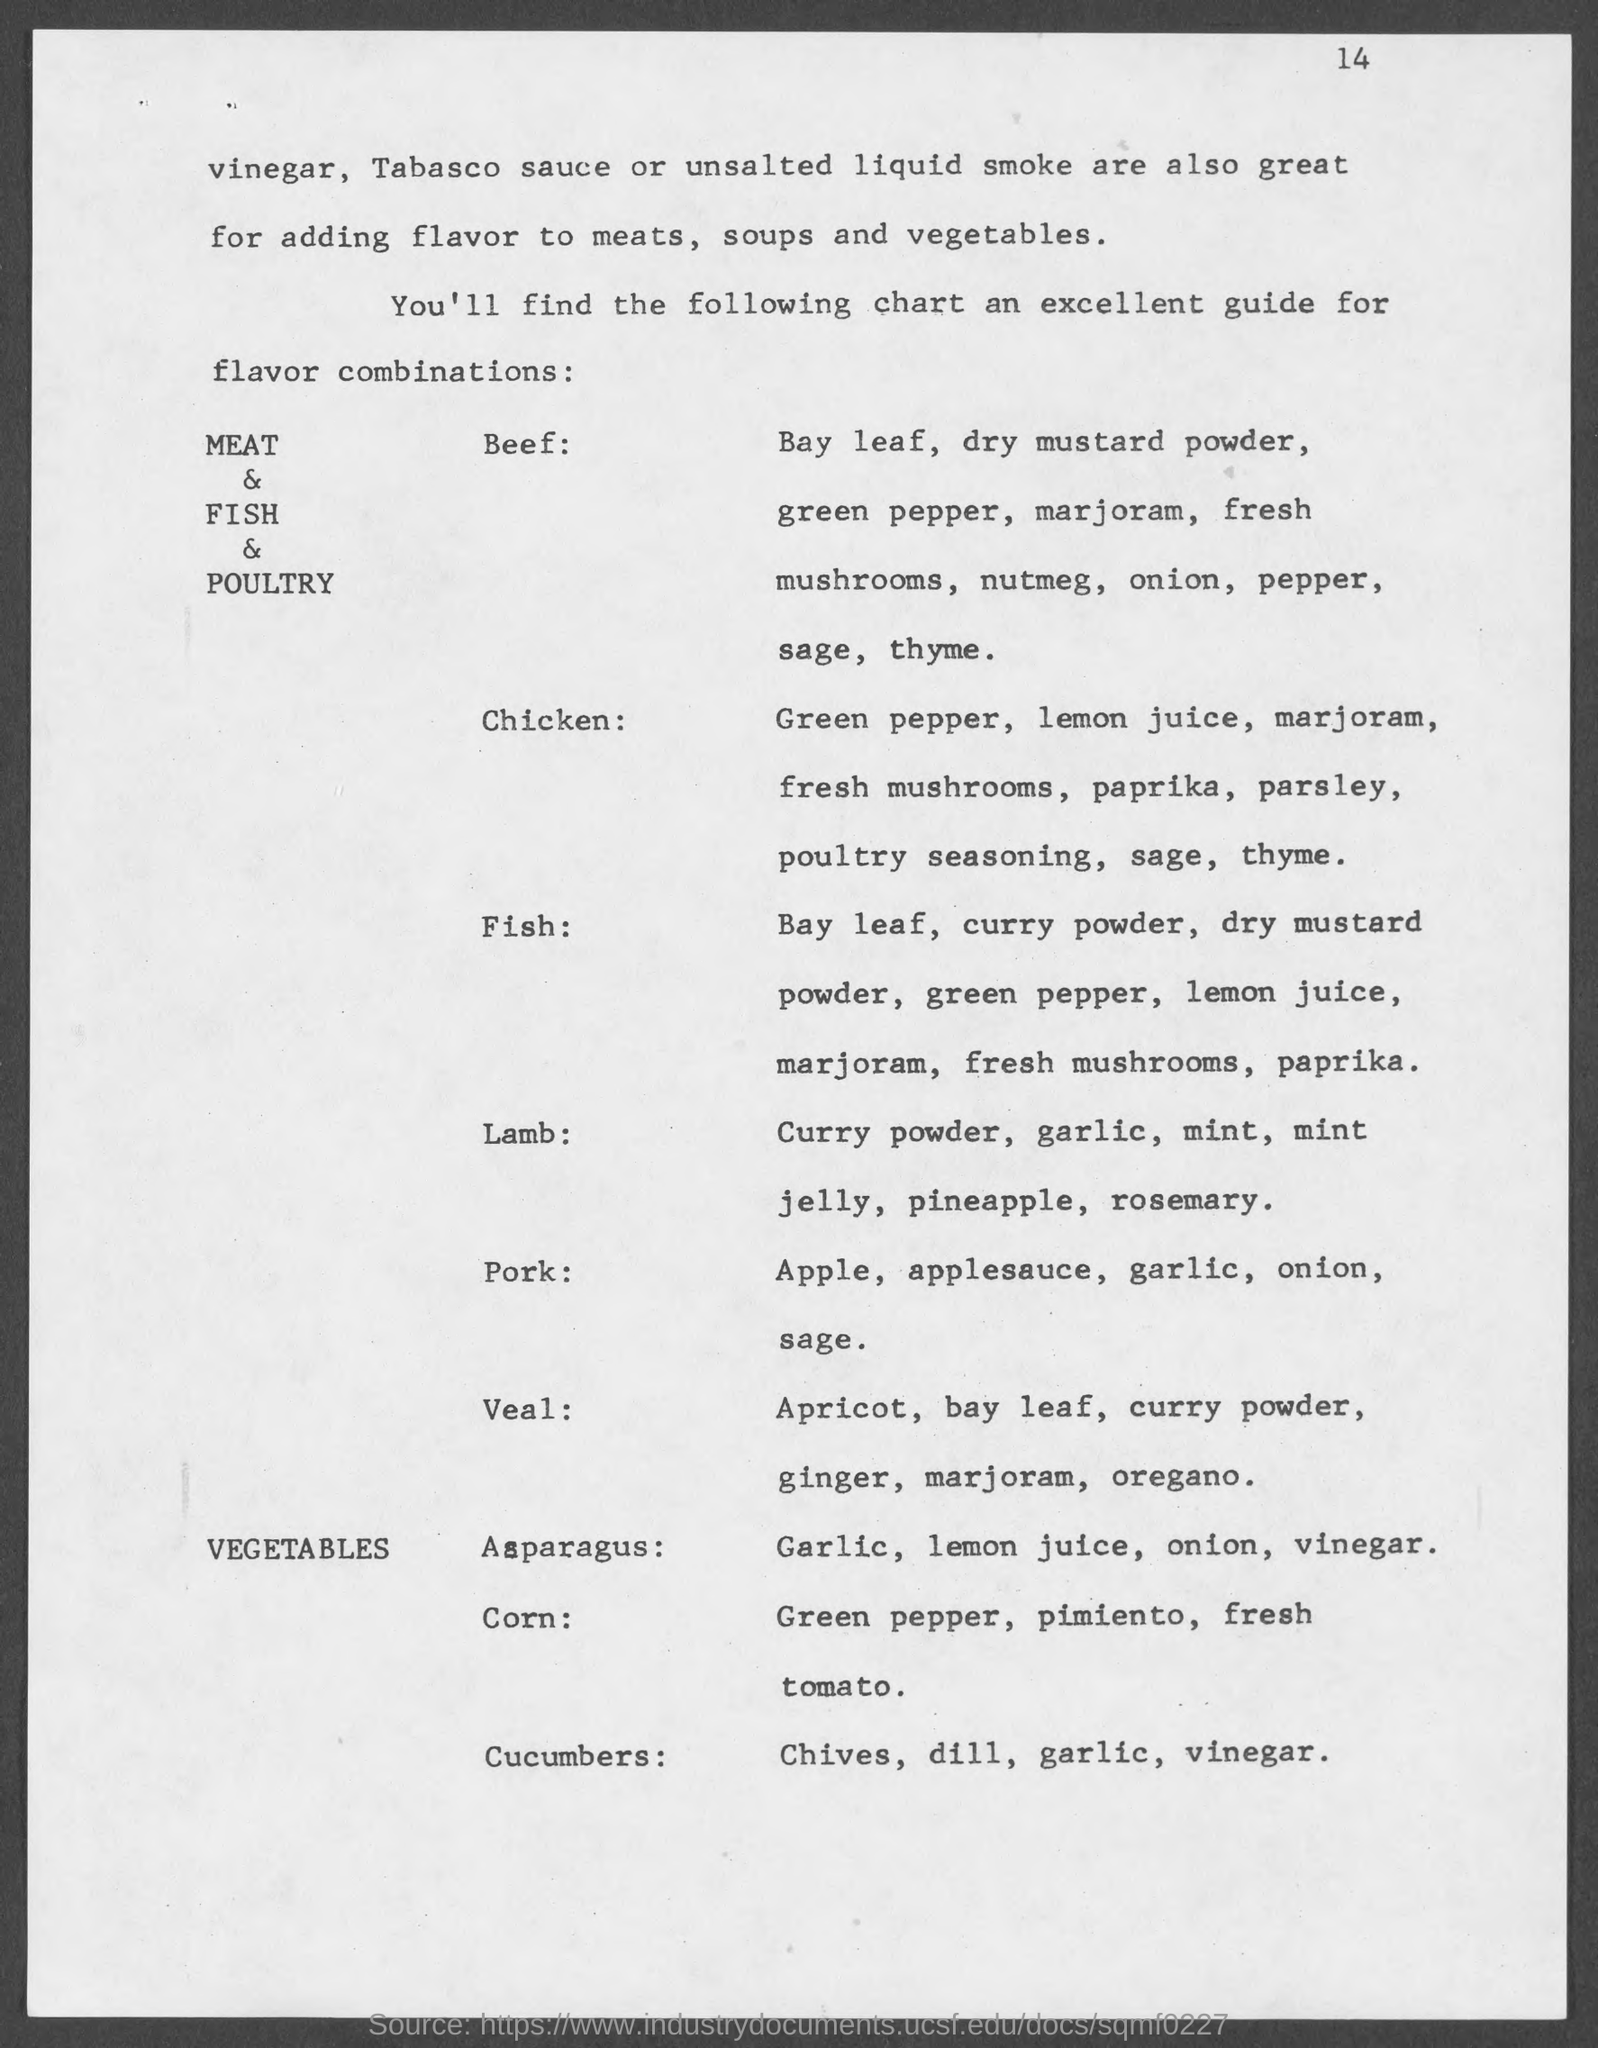List a handful of essential elements in this visual. The page number at the top of the page is 14. 